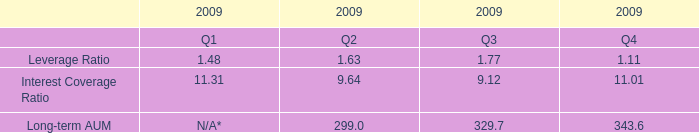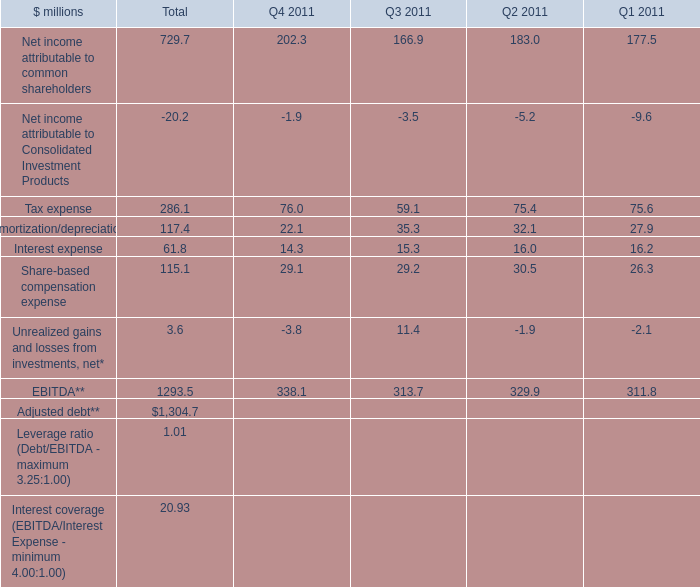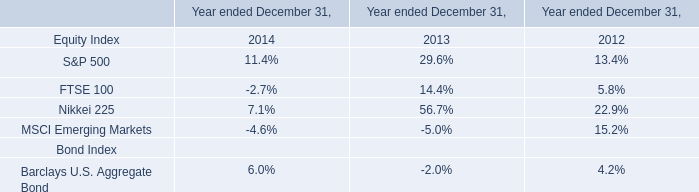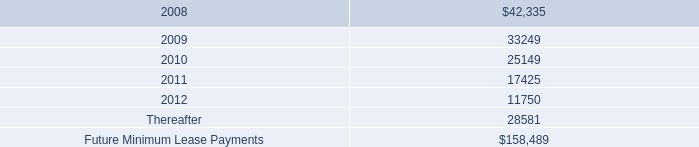What's the average of Interest expense in 2011? (in million) 
Computations: ((((14.3 + 15.3) + 16.0) + 16.2) / 4)
Answer: 15.45. 